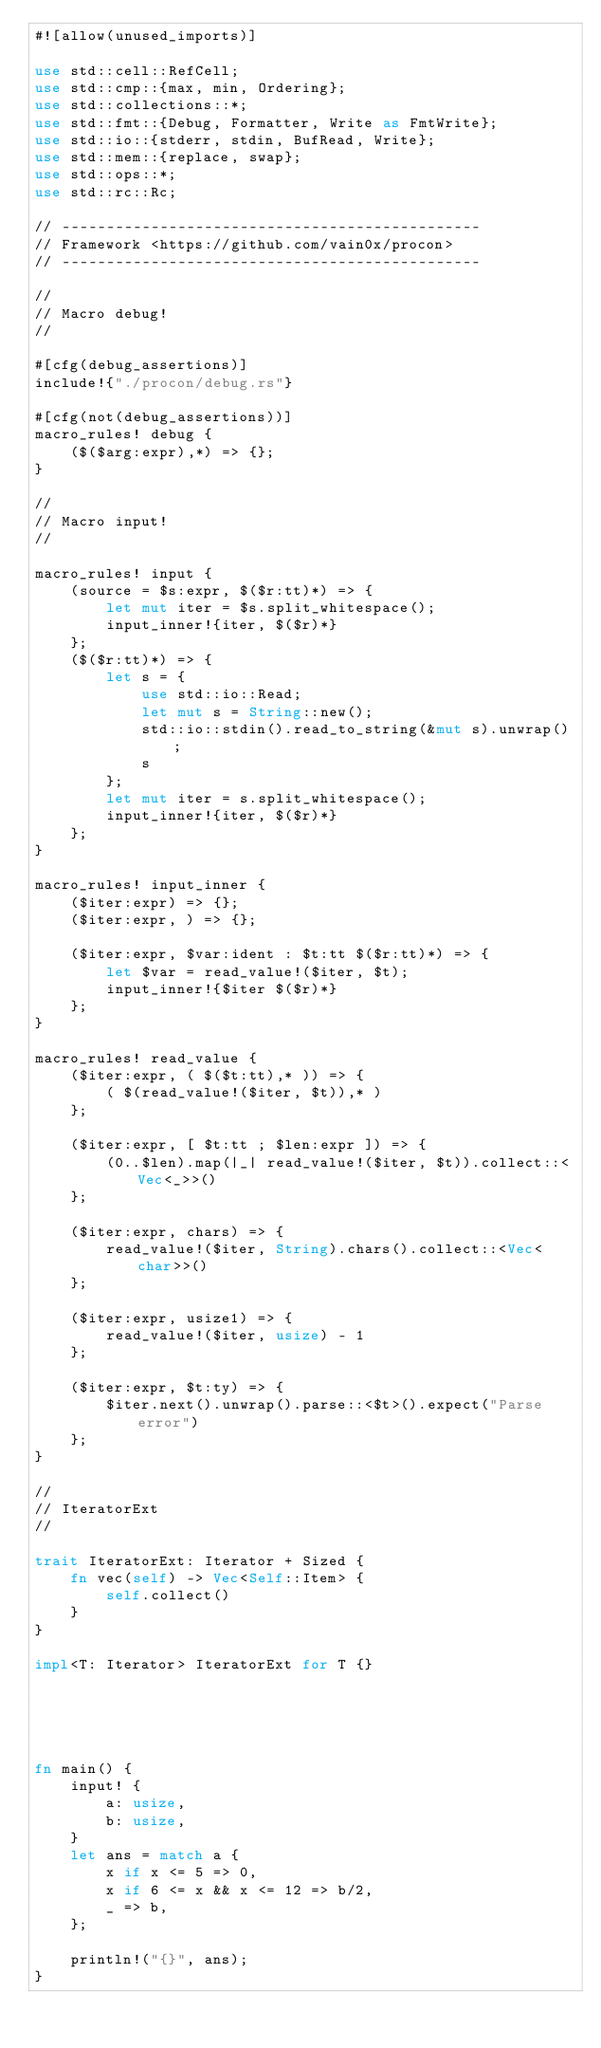Convert code to text. <code><loc_0><loc_0><loc_500><loc_500><_Rust_>#![allow(unused_imports)]

use std::cell::RefCell;
use std::cmp::{max, min, Ordering};
use std::collections::*;
use std::fmt::{Debug, Formatter, Write as FmtWrite};
use std::io::{stderr, stdin, BufRead, Write};
use std::mem::{replace, swap};
use std::ops::*;
use std::rc::Rc;

// -----------------------------------------------
// Framework <https://github.com/vain0x/procon>
// -----------------------------------------------

//
// Macro debug!
//

#[cfg(debug_assertions)]
include!{"./procon/debug.rs"}

#[cfg(not(debug_assertions))]
macro_rules! debug {
    ($($arg:expr),*) => {};
}

//
// Macro input!
//

macro_rules! input {
    (source = $s:expr, $($r:tt)*) => {
        let mut iter = $s.split_whitespace();
        input_inner!{iter, $($r)*}
    };
    ($($r:tt)*) => {
        let s = {
            use std::io::Read;
            let mut s = String::new();
            std::io::stdin().read_to_string(&mut s).unwrap();
            s
        };
        let mut iter = s.split_whitespace();
        input_inner!{iter, $($r)*}
    };
}

macro_rules! input_inner {
    ($iter:expr) => {};
    ($iter:expr, ) => {};

    ($iter:expr, $var:ident : $t:tt $($r:tt)*) => {
        let $var = read_value!($iter, $t);
        input_inner!{$iter $($r)*}
    };
}

macro_rules! read_value {
    ($iter:expr, ( $($t:tt),* )) => {
        ( $(read_value!($iter, $t)),* )
    };

    ($iter:expr, [ $t:tt ; $len:expr ]) => {
        (0..$len).map(|_| read_value!($iter, $t)).collect::<Vec<_>>()
    };

    ($iter:expr, chars) => {
        read_value!($iter, String).chars().collect::<Vec<char>>()
    };

    ($iter:expr, usize1) => {
        read_value!($iter, usize) - 1
    };

    ($iter:expr, $t:ty) => {
        $iter.next().unwrap().parse::<$t>().expect("Parse error")
    };
}

//
// IteratorExt
//

trait IteratorExt: Iterator + Sized {
    fn vec(self) -> Vec<Self::Item> {
        self.collect()
    }
}

impl<T: Iterator> IteratorExt for T {}





fn main() {
    input! {
        a: usize,
        b: usize,
    }
    let ans = match a {
        x if x <= 5 => 0,
        x if 6 <= x && x <= 12 => b/2,
        _ => b,
    };

    println!("{}", ans);
}
</code> 